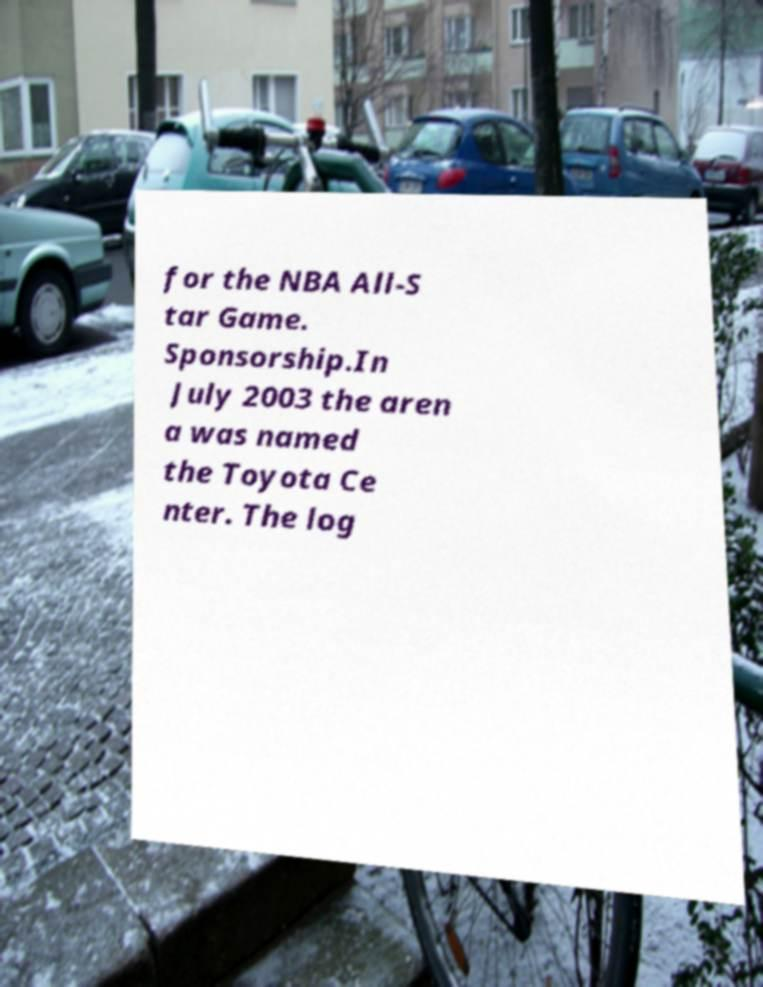Can you read and provide the text displayed in the image?This photo seems to have some interesting text. Can you extract and type it out for me? for the NBA All-S tar Game. Sponsorship.In July 2003 the aren a was named the Toyota Ce nter. The log 